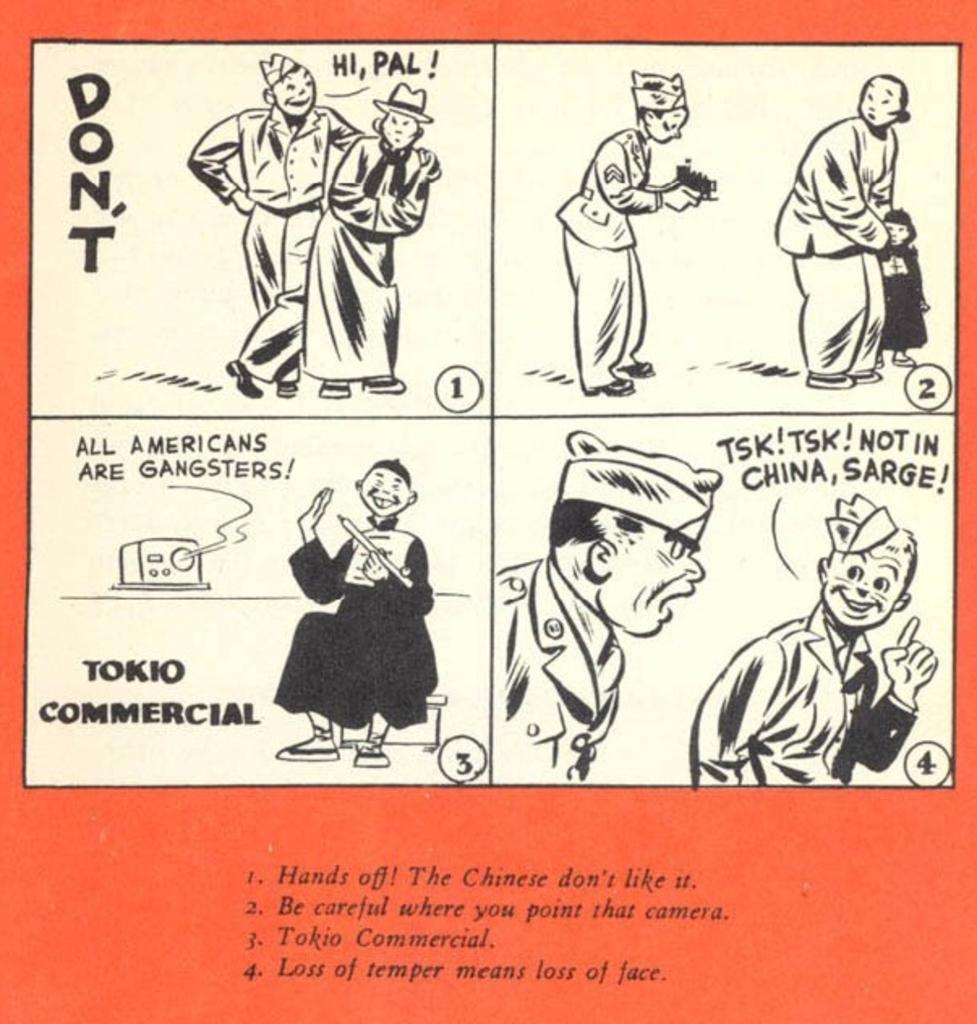What is present in the image that contains visual information? There is a poster in the image. What types of elements can be found on the poster? The poster contains images of people, letters, numbers, and objects. What color is the heart on the poster? There is no heart present on the poster; it contains images of people, letters, numbers, and objects. 